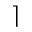Convert formula to latex. <formula><loc_0><loc_0><loc_500><loc_500>\rceil</formula> 